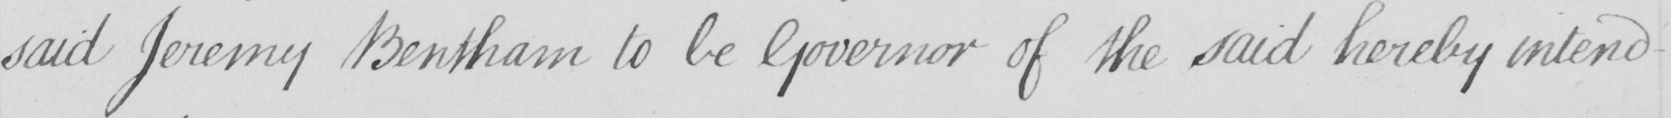What does this handwritten line say? said Jeremy Bentham to be Governor of the said hereby intend- 